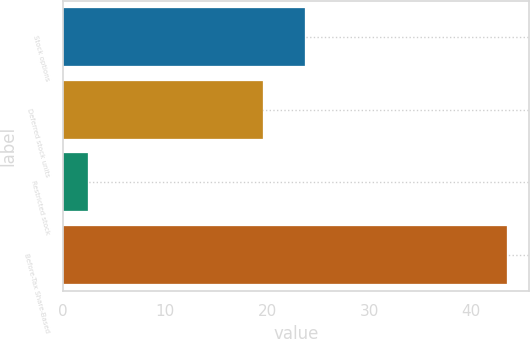Convert chart to OTSL. <chart><loc_0><loc_0><loc_500><loc_500><bar_chart><fcel>Stock options<fcel>Deferred stock units<fcel>Restricted stock<fcel>Before-Tax Share-Based<nl><fcel>23.71<fcel>19.6<fcel>2.4<fcel>43.5<nl></chart> 